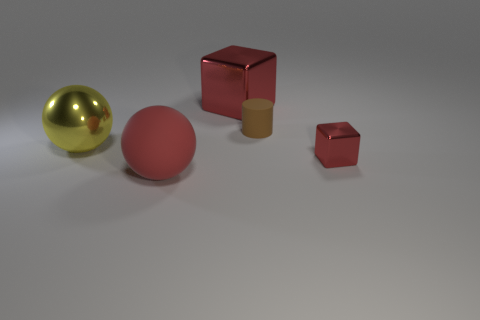What size is the red shiny block that is in front of the big red object behind the small shiny object?
Your response must be concise. Small. There is a red metallic object behind the big metallic thing that is in front of the rubber thing that is behind the small shiny object; what shape is it?
Offer a very short reply. Cube. What color is the large sphere that is the same material as the large block?
Provide a succinct answer. Yellow. There is a matte thing that is behind the big red thing that is left of the object that is behind the small rubber thing; what color is it?
Provide a short and direct response. Brown. How many spheres are either tiny metallic objects or tiny brown objects?
Your answer should be compact. 0. What is the material of the large cube that is the same color as the small cube?
Ensure brevity in your answer.  Metal. Do the small shiny object and the cube behind the large metal ball have the same color?
Ensure brevity in your answer.  Yes. The small metal block has what color?
Your answer should be compact. Red. How many things are small metal objects or big metal objects?
Offer a terse response. 3. There is a block that is the same size as the brown rubber object; what is it made of?
Keep it short and to the point. Metal. 